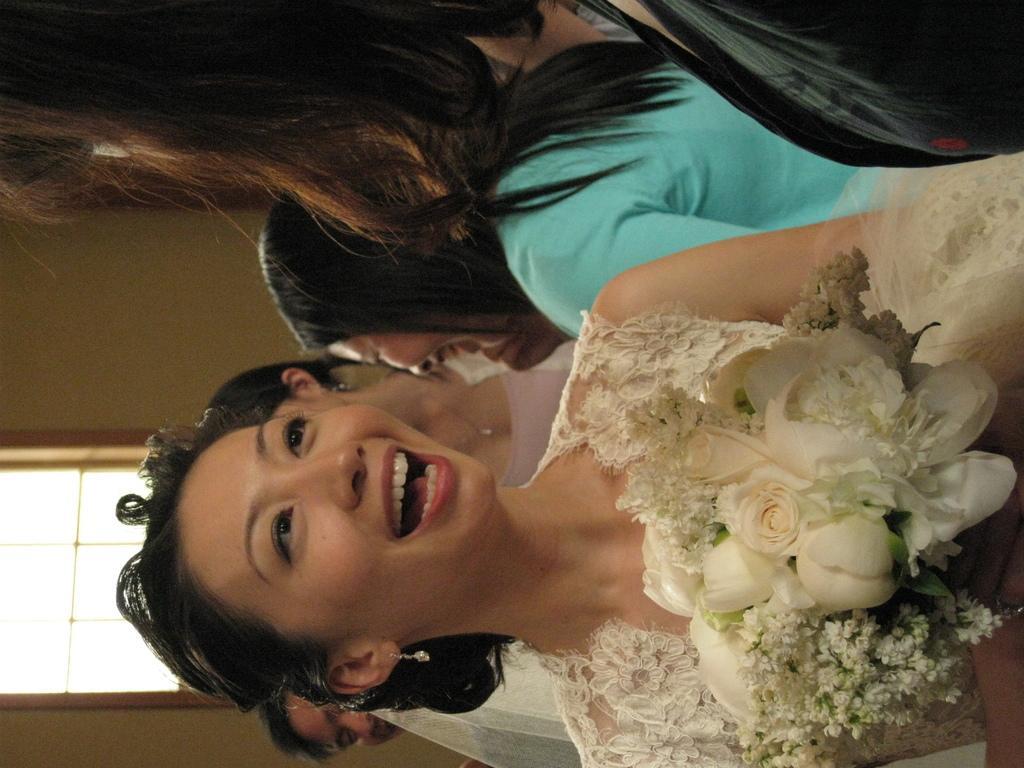In one or two sentences, can you explain what this image depicts? In this image there is one woman who is standing and she is holding a flower bouquet, and in the background there are some people who are standing. And also on the left side there is a wall and a window. 